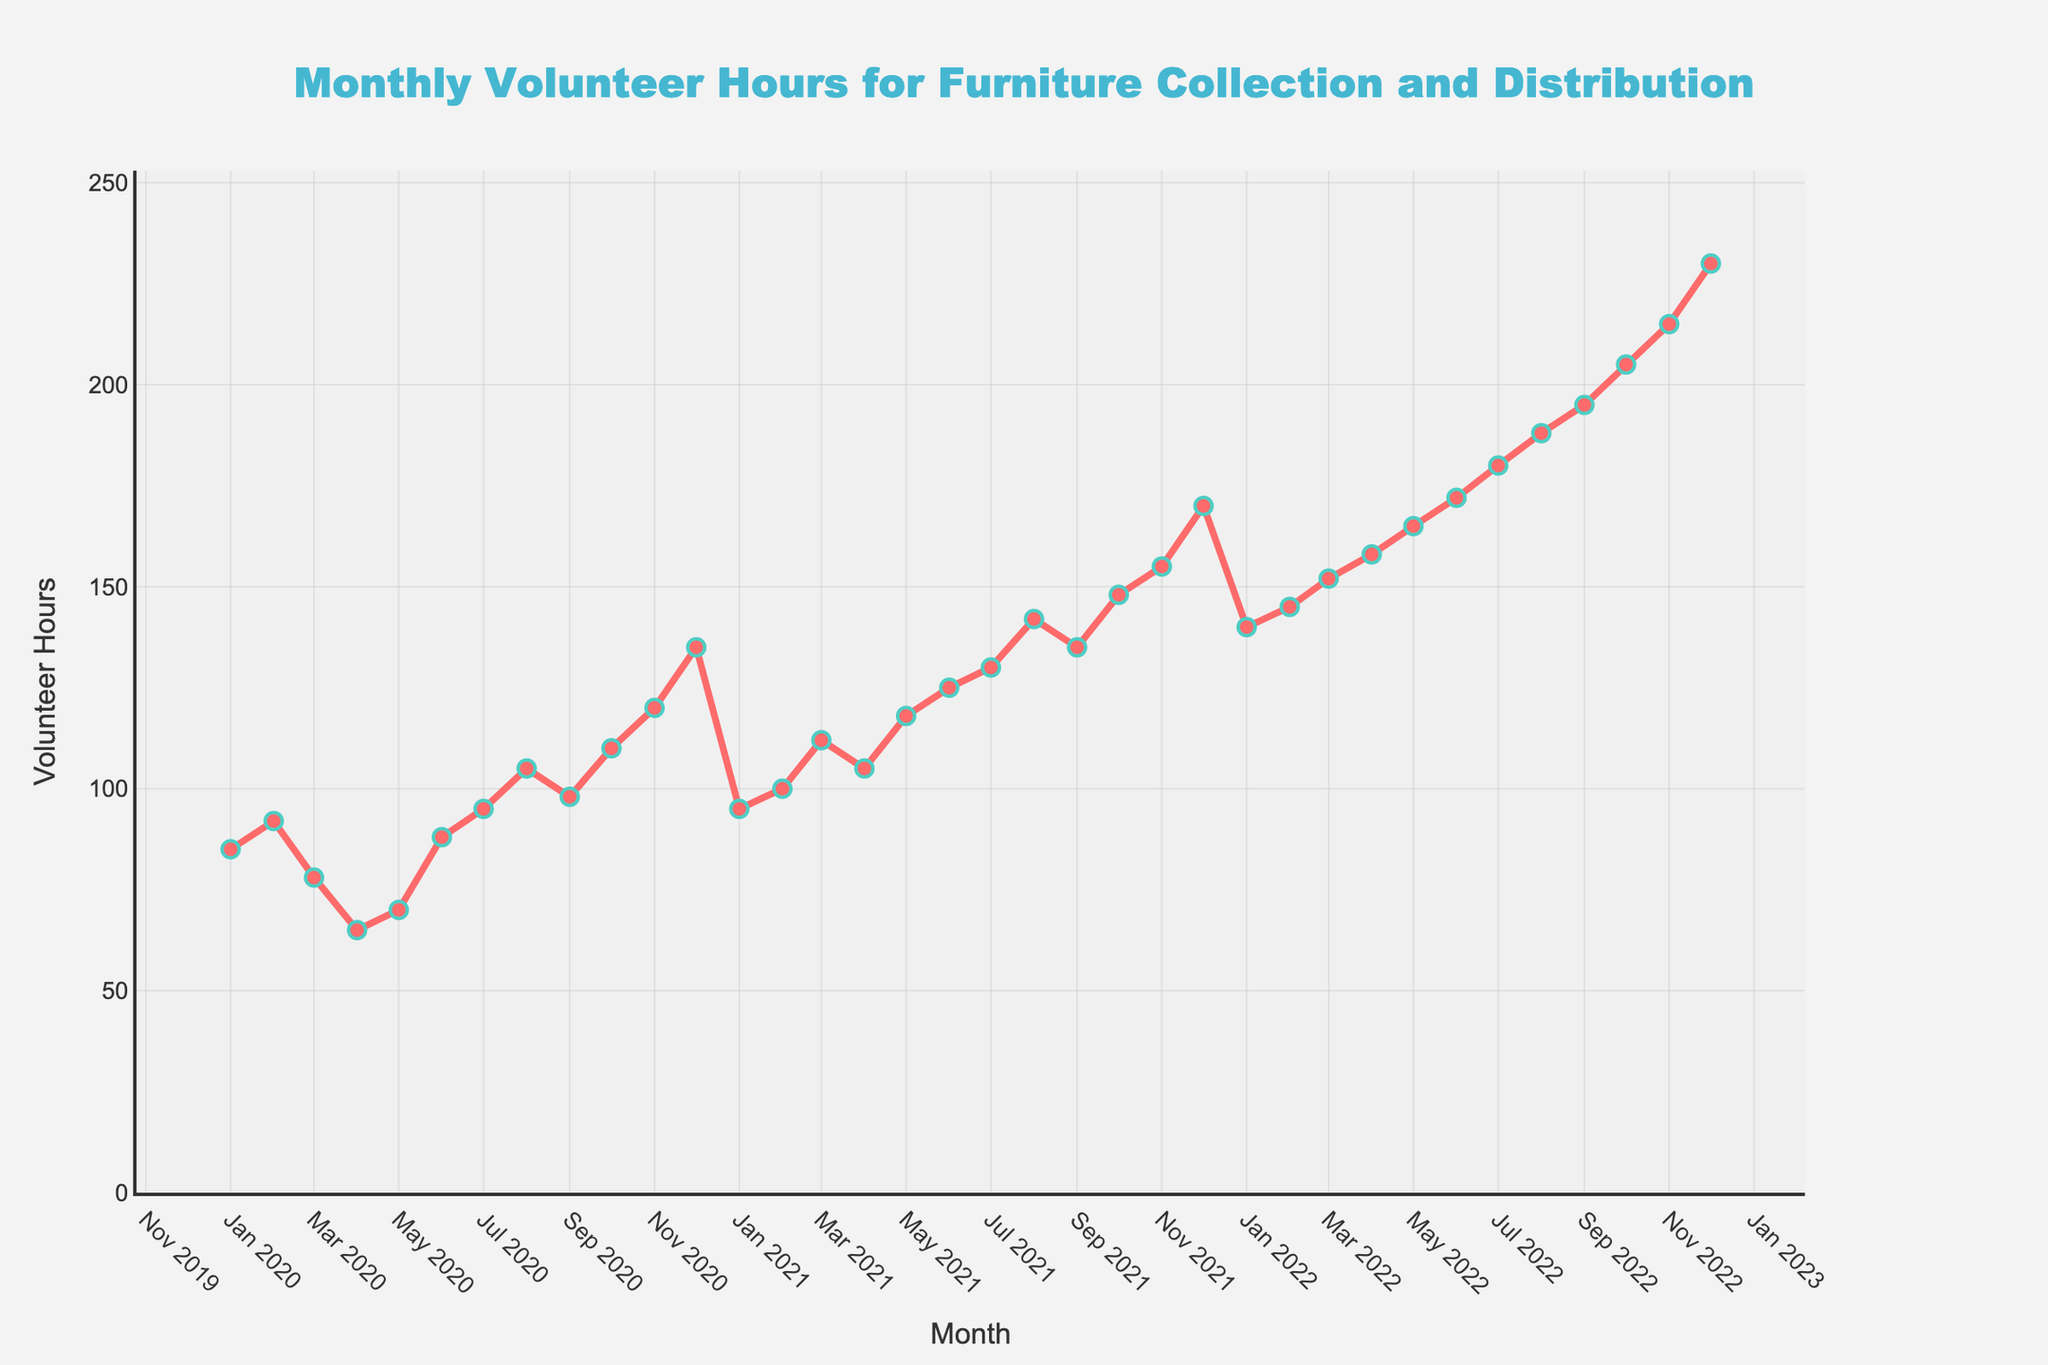what is the highest number of volunteer hours recorded in a month in 2020? In 2020, the highest number of volunteer hours recorded in a month is observed in December on the y-axis. The value is 135 hours.
Answer: 135 Compare the volunteer hours between July 2021 and July 2022. Which month had more volunteer hours? To compare, we look at the y-axis values for both months. In July 2021, there are 130 volunteer hours, and in July 2022, there are 180 volunteer hours. July 2022 had more volunteer hours.
Answer: July 2022 What is the difference in volunteer hours between December 2021 and December 2022? We find the y-axis values for December 2021 and December 2022. December 2021 has 170 volunteer hours, and December 2022 has 230 volunteer hours. Subtracting these gives 230 - 170.
Answer: 60 What is the average number of volunteer hours per month for the year 2021? For 2021, sum the volunteer hours of each month and divide by 12. The sum is 95 + 100 + 112 + 105 + 118 + 125 + 130 + 142 + 135 + 148 + 155 + 170 = 1535. Dividing by 12 gives 1535 / 12.
Answer: 128 During which months in 2022 did the volunteer hours exceed 190? We look for points in 2022 where the y-axis value exceeds 190. This occurs from September (195), October (205), November (215), and December (230).
Answer: September, October, November, December Identify the trend of volunteer hours from Jan 2020 to Dec 2022. The trend can be observed by following the line and markers. The overall trend shows an increase in volunteer hours from Jan 2020 to Dec 2022.
Answer: Increasing What is the difference in volunteer hours between January 2020 and January 2022? Look at the y-axis values for January 2020 (85 hours) and January 2022 (140 hours). The difference is 140 - 85.
Answer: 55 Which month saw the greatest increase in volunteer hours between consecutive months in 2021? By comparing the volunteer hours month-by-month in 2021, the largest jump is from February (100) to March (112), which is 112 - 100 = 12 hours increase.
Answer: February to March What visual color is used to represent the volunteer hours line on the chart? Observing the line color for volunteer hours, it is displayed in red.
Answer: Red 